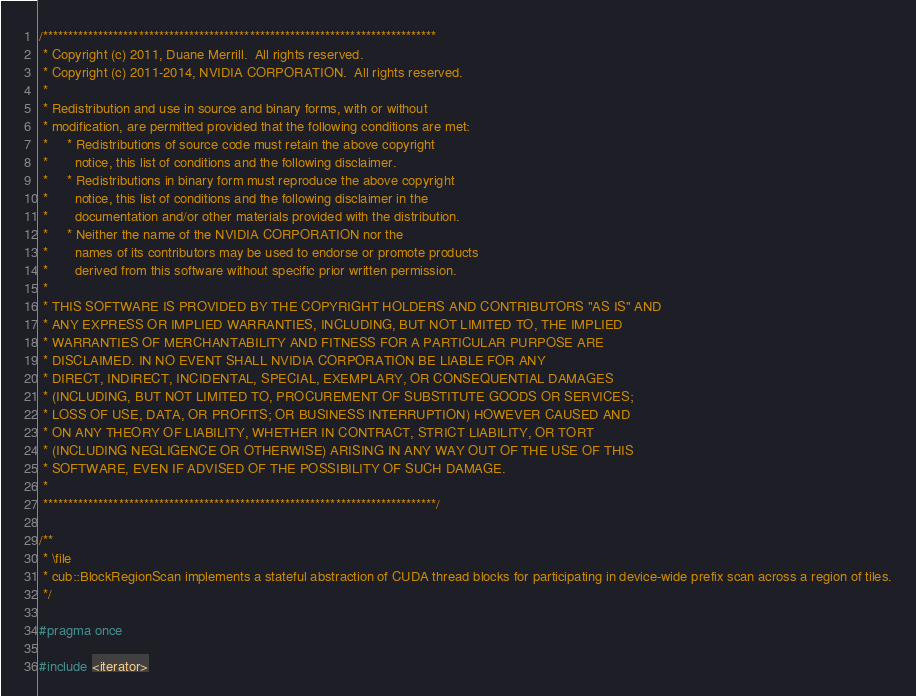Convert code to text. <code><loc_0><loc_0><loc_500><loc_500><_Cuda_>/******************************************************************************
 * Copyright (c) 2011, Duane Merrill.  All rights reserved.
 * Copyright (c) 2011-2014, NVIDIA CORPORATION.  All rights reserved.
 *
 * Redistribution and use in source and binary forms, with or without
 * modification, are permitted provided that the following conditions are met:
 *     * Redistributions of source code must retain the above copyright
 *       notice, this list of conditions and the following disclaimer.
 *     * Redistributions in binary form must reproduce the above copyright
 *       notice, this list of conditions and the following disclaimer in the
 *       documentation and/or other materials provided with the distribution.
 *     * Neither the name of the NVIDIA CORPORATION nor the
 *       names of its contributors may be used to endorse or promote products
 *       derived from this software without specific prior written permission.
 *
 * THIS SOFTWARE IS PROVIDED BY THE COPYRIGHT HOLDERS AND CONTRIBUTORS "AS IS" AND
 * ANY EXPRESS OR IMPLIED WARRANTIES, INCLUDING, BUT NOT LIMITED TO, THE IMPLIED
 * WARRANTIES OF MERCHANTABILITY AND FITNESS FOR A PARTICULAR PURPOSE ARE
 * DISCLAIMED. IN NO EVENT SHALL NVIDIA CORPORATION BE LIABLE FOR ANY
 * DIRECT, INDIRECT, INCIDENTAL, SPECIAL, EXEMPLARY, OR CONSEQUENTIAL DAMAGES
 * (INCLUDING, BUT NOT LIMITED TO, PROCUREMENT OF SUBSTITUTE GOODS OR SERVICES;
 * LOSS OF USE, DATA, OR PROFITS; OR BUSINESS INTERRUPTION) HOWEVER CAUSED AND
 * ON ANY THEORY OF LIABILITY, WHETHER IN CONTRACT, STRICT LIABILITY, OR TORT
 * (INCLUDING NEGLIGENCE OR OTHERWISE) ARISING IN ANY WAY OUT OF THE USE OF THIS
 * SOFTWARE, EVEN IF ADVISED OF THE POSSIBILITY OF SUCH DAMAGE.
 *
 ******************************************************************************/

/**
 * \file
 * cub::BlockRegionScan implements a stateful abstraction of CUDA thread blocks for participating in device-wide prefix scan across a region of tiles.
 */

#pragma once

#include <iterator>
</code> 